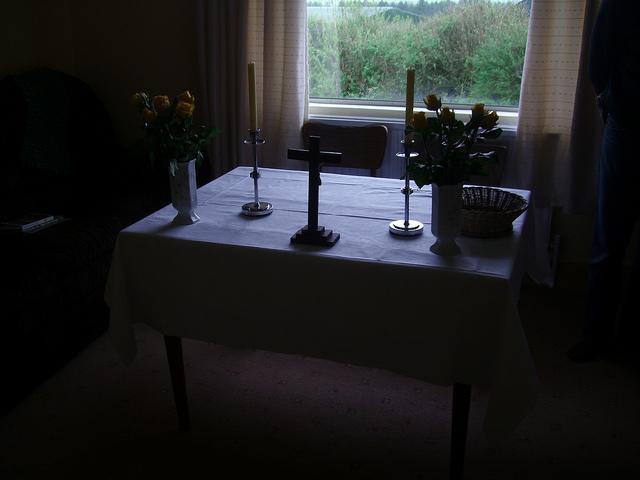How many candles are there?
Give a very brief answer. 2. How many potted plants are visible?
Give a very brief answer. 2. How many vases are in the photo?
Give a very brief answer. 1. How many orange cones are there?
Give a very brief answer. 0. 